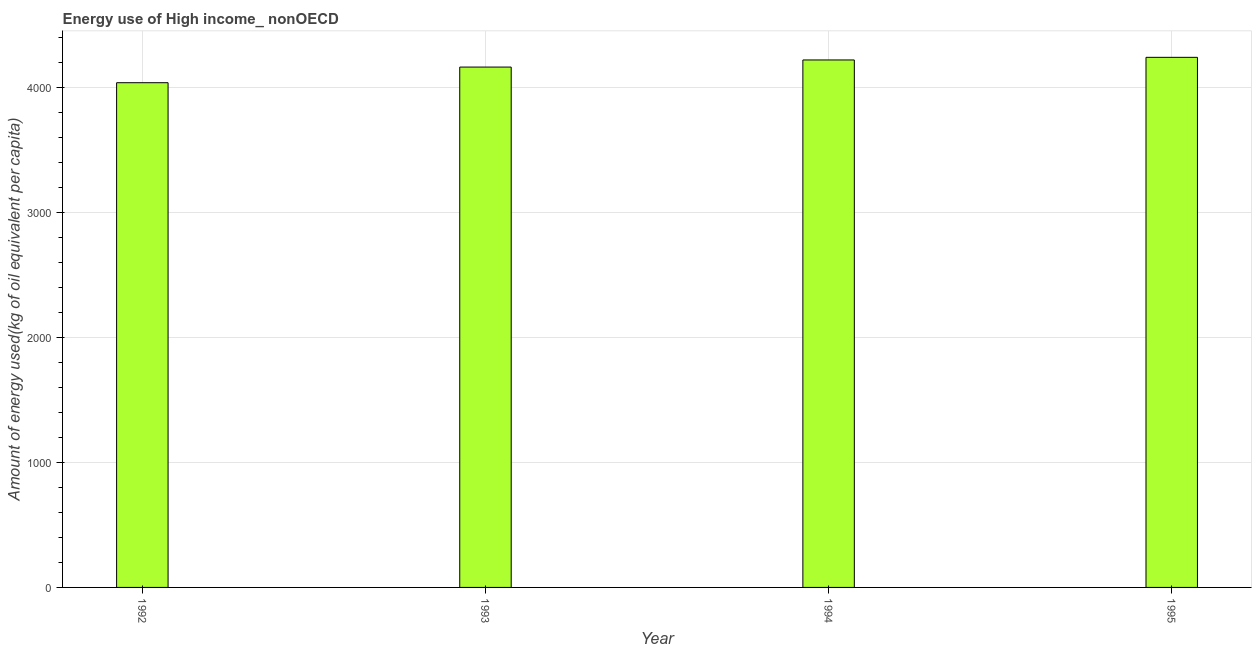Does the graph contain any zero values?
Provide a succinct answer. No. What is the title of the graph?
Make the answer very short. Energy use of High income_ nonOECD. What is the label or title of the X-axis?
Provide a short and direct response. Year. What is the label or title of the Y-axis?
Make the answer very short. Amount of energy used(kg of oil equivalent per capita). What is the amount of energy used in 1992?
Keep it short and to the point. 4038.66. Across all years, what is the maximum amount of energy used?
Give a very brief answer. 4241.74. Across all years, what is the minimum amount of energy used?
Offer a terse response. 4038.66. In which year was the amount of energy used maximum?
Give a very brief answer. 1995. What is the sum of the amount of energy used?
Your response must be concise. 1.67e+04. What is the difference between the amount of energy used in 1993 and 1995?
Provide a short and direct response. -77.98. What is the average amount of energy used per year?
Provide a succinct answer. 4166.22. What is the median amount of energy used?
Give a very brief answer. 4192.23. In how many years, is the amount of energy used greater than 3800 kg?
Ensure brevity in your answer.  4. Do a majority of the years between 1992 and 1995 (inclusive) have amount of energy used greater than 3800 kg?
Offer a very short reply. Yes. What is the ratio of the amount of energy used in 1993 to that in 1994?
Offer a very short reply. 0.99. Is the difference between the amount of energy used in 1994 and 1995 greater than the difference between any two years?
Your answer should be very brief. No. What is the difference between the highest and the second highest amount of energy used?
Keep it short and to the point. 21.04. Is the sum of the amount of energy used in 1993 and 1994 greater than the maximum amount of energy used across all years?
Offer a very short reply. Yes. What is the difference between the highest and the lowest amount of energy used?
Provide a short and direct response. 203.08. In how many years, is the amount of energy used greater than the average amount of energy used taken over all years?
Your answer should be very brief. 2. Are all the bars in the graph horizontal?
Your answer should be compact. No. Are the values on the major ticks of Y-axis written in scientific E-notation?
Keep it short and to the point. No. What is the Amount of energy used(kg of oil equivalent per capita) in 1992?
Provide a succinct answer. 4038.66. What is the Amount of energy used(kg of oil equivalent per capita) of 1993?
Ensure brevity in your answer.  4163.76. What is the Amount of energy used(kg of oil equivalent per capita) of 1994?
Ensure brevity in your answer.  4220.7. What is the Amount of energy used(kg of oil equivalent per capita) in 1995?
Ensure brevity in your answer.  4241.74. What is the difference between the Amount of energy used(kg of oil equivalent per capita) in 1992 and 1993?
Offer a terse response. -125.1. What is the difference between the Amount of energy used(kg of oil equivalent per capita) in 1992 and 1994?
Your answer should be very brief. -182.04. What is the difference between the Amount of energy used(kg of oil equivalent per capita) in 1992 and 1995?
Provide a succinct answer. -203.08. What is the difference between the Amount of energy used(kg of oil equivalent per capita) in 1993 and 1994?
Keep it short and to the point. -56.94. What is the difference between the Amount of energy used(kg of oil equivalent per capita) in 1993 and 1995?
Offer a very short reply. -77.98. What is the difference between the Amount of energy used(kg of oil equivalent per capita) in 1994 and 1995?
Offer a very short reply. -21.04. What is the ratio of the Amount of energy used(kg of oil equivalent per capita) in 1992 to that in 1993?
Offer a terse response. 0.97. What is the ratio of the Amount of energy used(kg of oil equivalent per capita) in 1992 to that in 1994?
Offer a terse response. 0.96. What is the ratio of the Amount of energy used(kg of oil equivalent per capita) in 1993 to that in 1995?
Your answer should be compact. 0.98. 